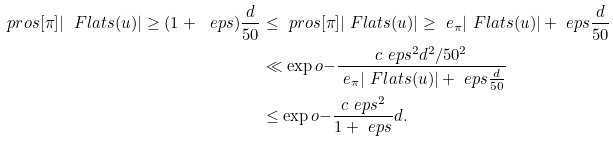<formula> <loc_0><loc_0><loc_500><loc_500>\ p r o s [ \pi ] { | \ F l a t s ( u ) | \geq ( 1 + \ e p s ) \frac { d } { 5 0 } } & \leq \ p r o s [ \pi ] { | \ F l a t s ( u ) | \geq \ e _ { \pi } | \ F l a t s ( u ) | + \ e p s \frac { d } { 5 0 } } \\ & \ll \exp o { - \frac { c \ e p s ^ { 2 } d ^ { 2 } / 5 0 ^ { 2 } } { \ e _ { \pi } | \ F l a t s ( u ) | + \ e p s \frac { d } { 5 0 } } } \\ & \leq \exp o { - \frac { c \ e p s ^ { 2 } } { 1 + \ e p s } d } .</formula> 